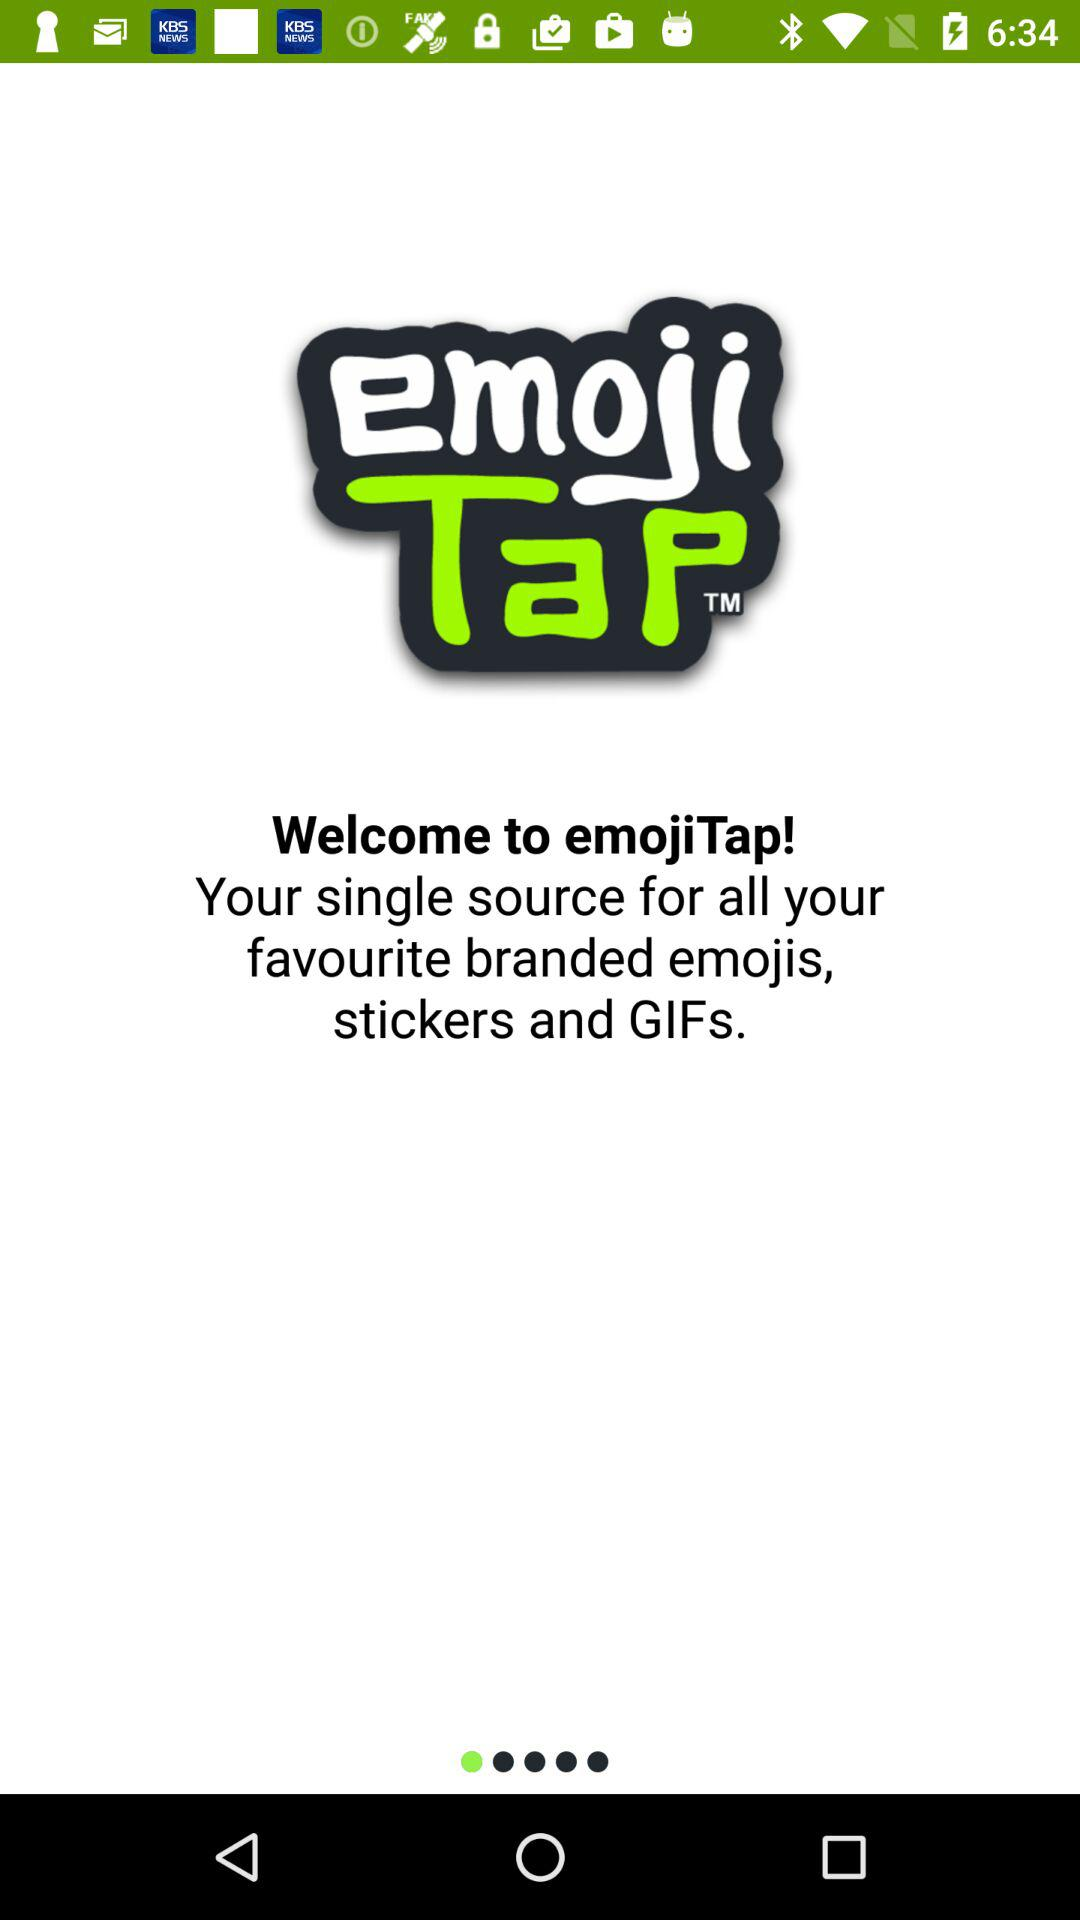What is the application name? The application name is "emojiTap". 